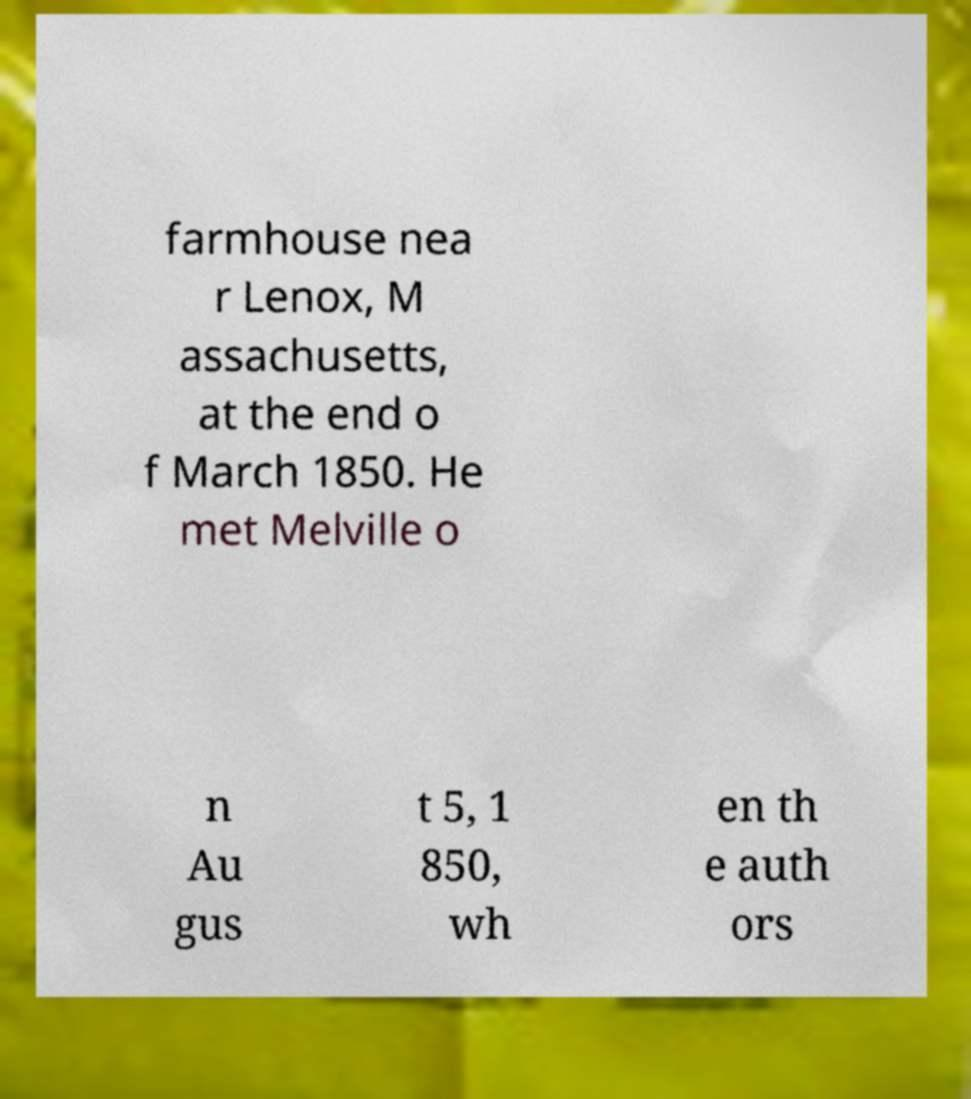I need the written content from this picture converted into text. Can you do that? farmhouse nea r Lenox, M assachusetts, at the end o f March 1850. He met Melville o n Au gus t 5, 1 850, wh en th e auth ors 